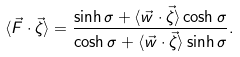<formula> <loc_0><loc_0><loc_500><loc_500>\langle \vec { F } \cdot \vec { \zeta } \rangle = \frac { \sinh \sigma + \langle \vec { w } \cdot \vec { \zeta } \rangle \cosh \sigma } { \cosh \sigma + \langle \vec { w } \cdot \vec { \zeta } \rangle \sinh \sigma } .</formula> 